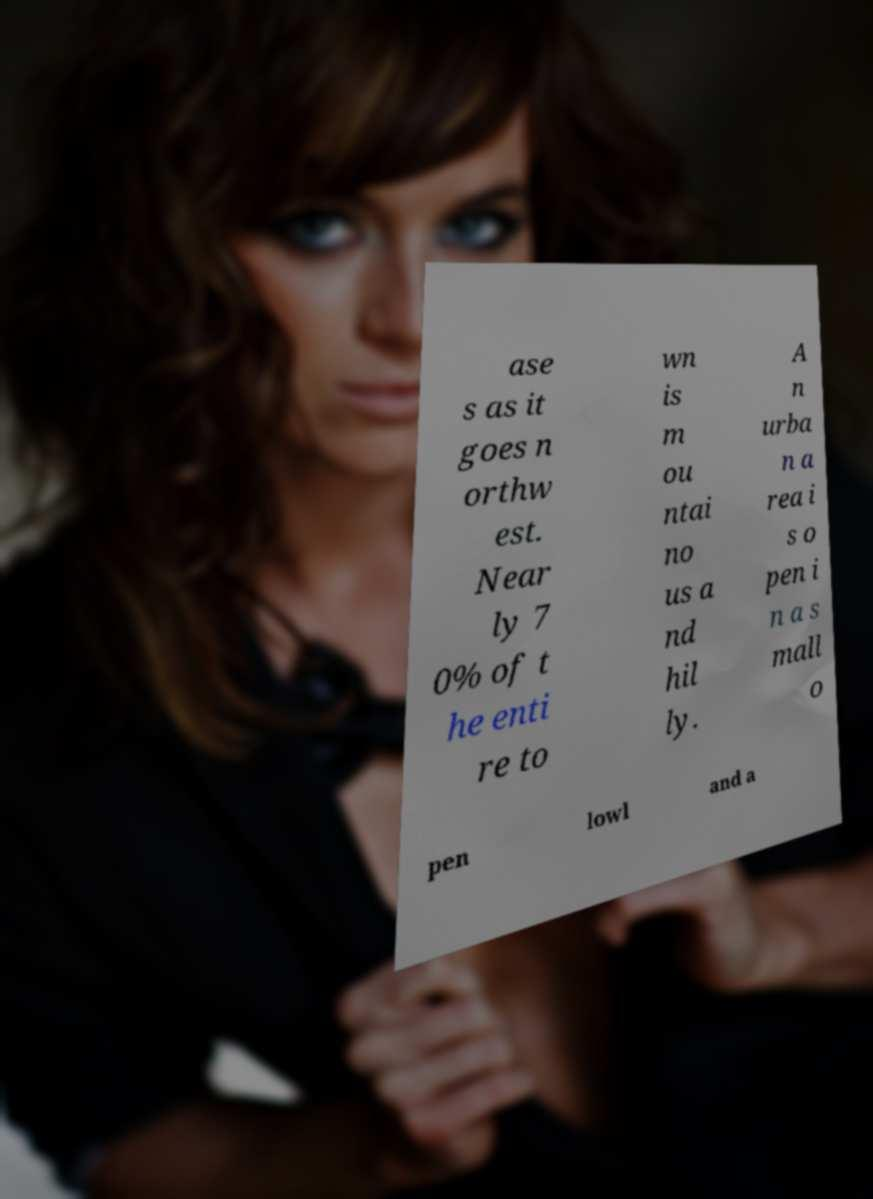Can you accurately transcribe the text from the provided image for me? ase s as it goes n orthw est. Near ly 7 0% of t he enti re to wn is m ou ntai no us a nd hil ly. A n urba n a rea i s o pen i n a s mall o pen lowl and a 